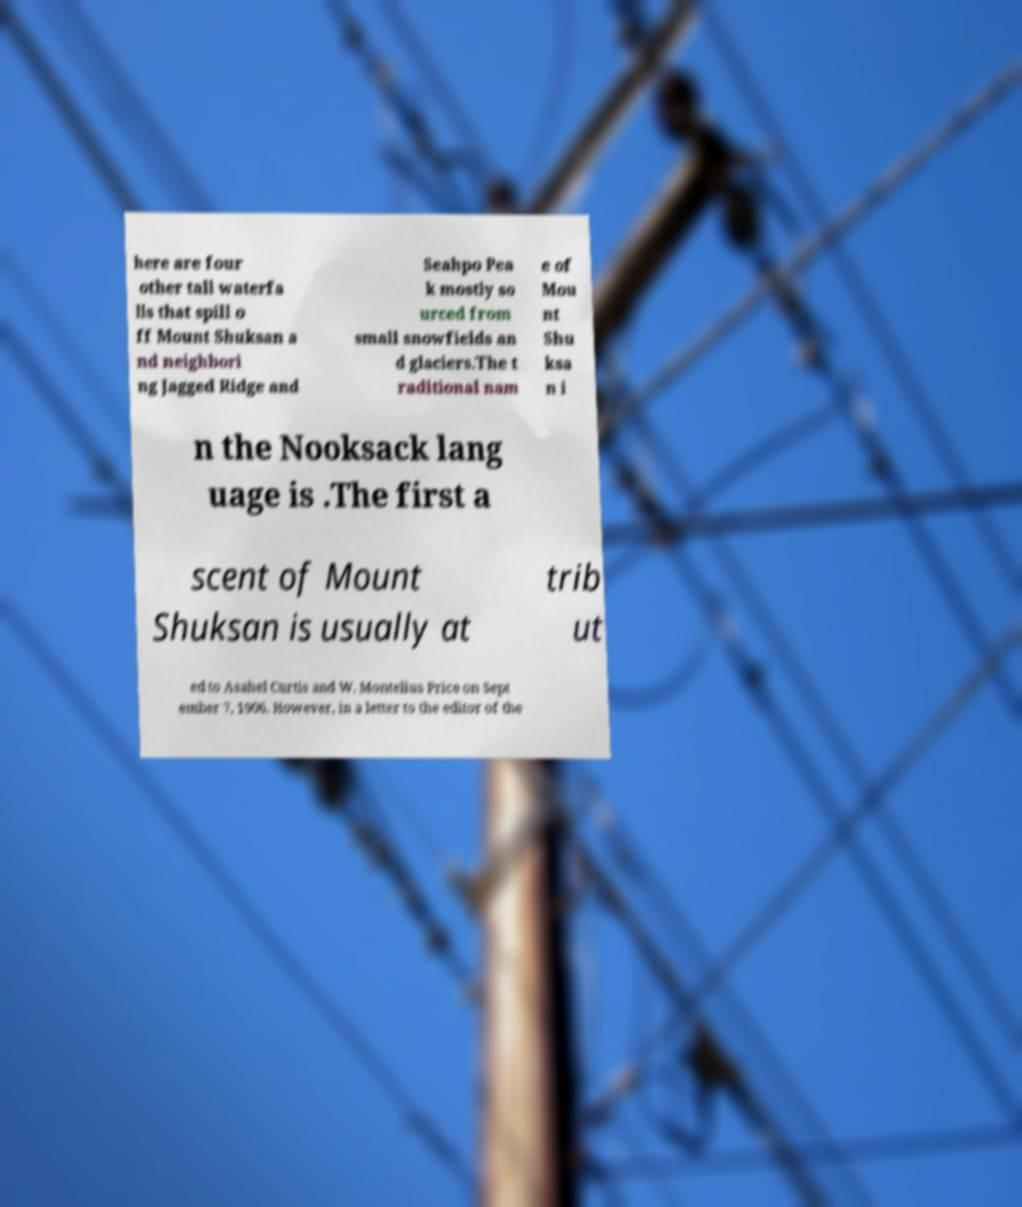I need the written content from this picture converted into text. Can you do that? here are four other tall waterfa lls that spill o ff Mount Shuksan a nd neighbori ng Jagged Ridge and Seahpo Pea k mostly so urced from small snowfields an d glaciers.The t raditional nam e of Mou nt Shu ksa n i n the Nooksack lang uage is .The first a scent of Mount Shuksan is usually at trib ut ed to Asahel Curtis and W. Montelius Price on Sept ember 7, 1906. However, in a letter to the editor of the 